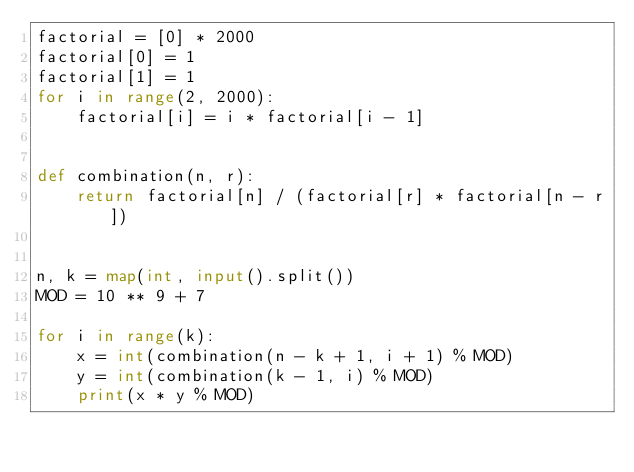Convert code to text. <code><loc_0><loc_0><loc_500><loc_500><_Python_>factorial = [0] * 2000
factorial[0] = 1
factorial[1] = 1
for i in range(2, 2000):
    factorial[i] = i * factorial[i - 1]


def combination(n, r):
    return factorial[n] / (factorial[r] * factorial[n - r])


n, k = map(int, input().split())
MOD = 10 ** 9 + 7

for i in range(k):
    x = int(combination(n - k + 1, i + 1) % MOD)
    y = int(combination(k - 1, i) % MOD)
    print(x * y % MOD)</code> 